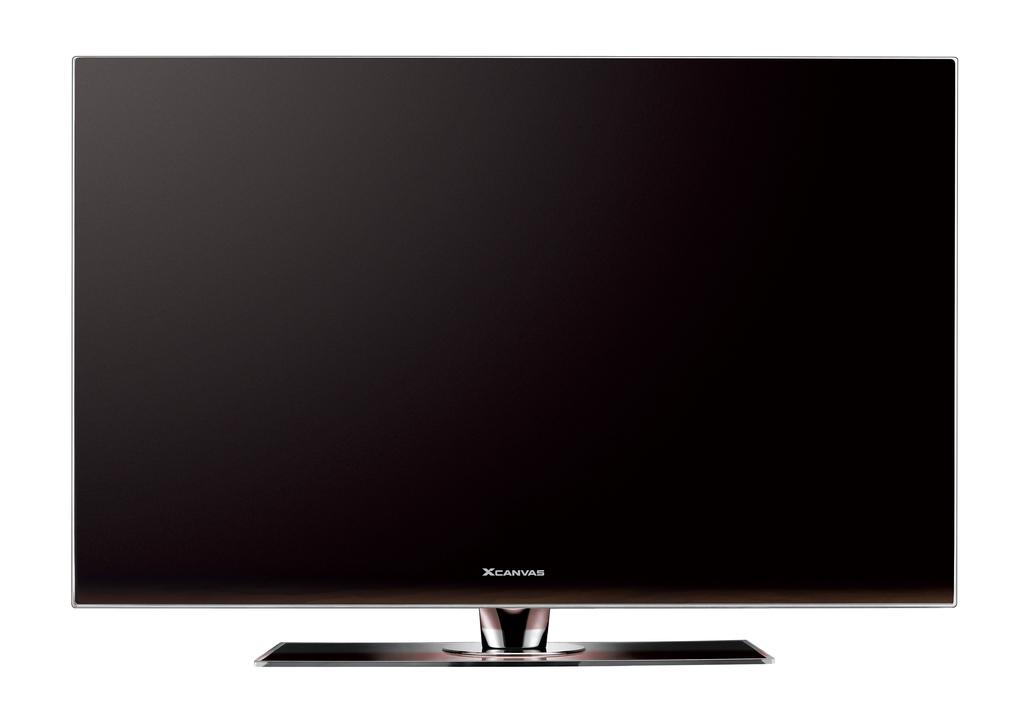Provide a one-sentence caption for the provided image. A shot of a xcanvas monitor with a blank screen. 